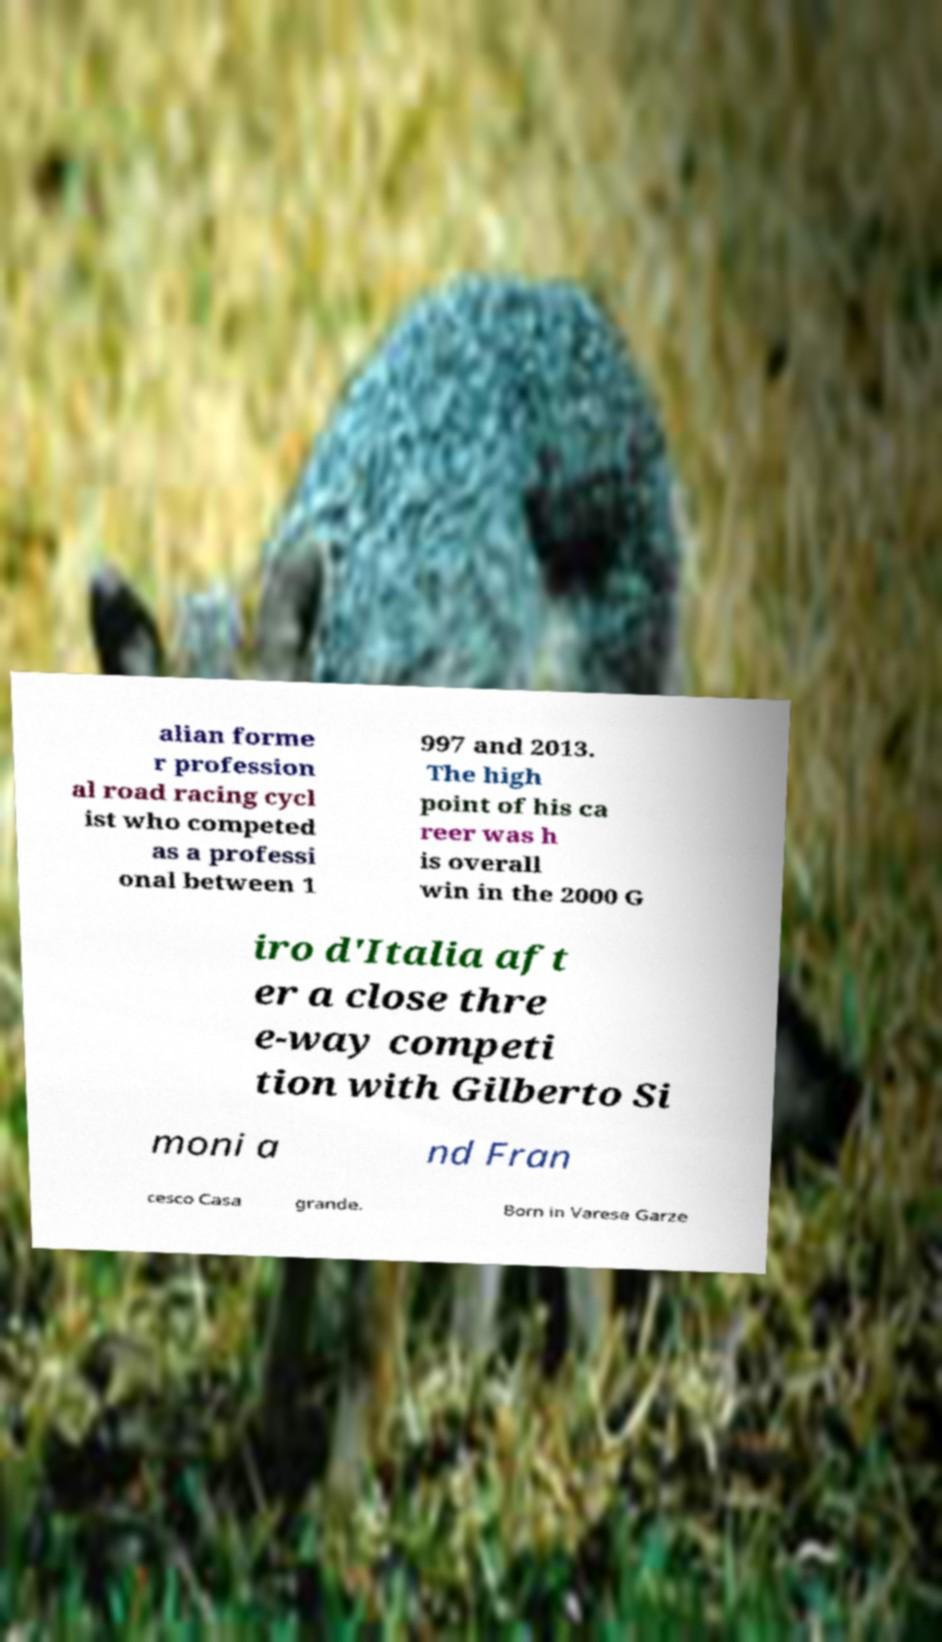For documentation purposes, I need the text within this image transcribed. Could you provide that? alian forme r profession al road racing cycl ist who competed as a professi onal between 1 997 and 2013. The high point of his ca reer was h is overall win in the 2000 G iro d'Italia aft er a close thre e-way competi tion with Gilberto Si moni a nd Fran cesco Casa grande. Born in Varese Garze 